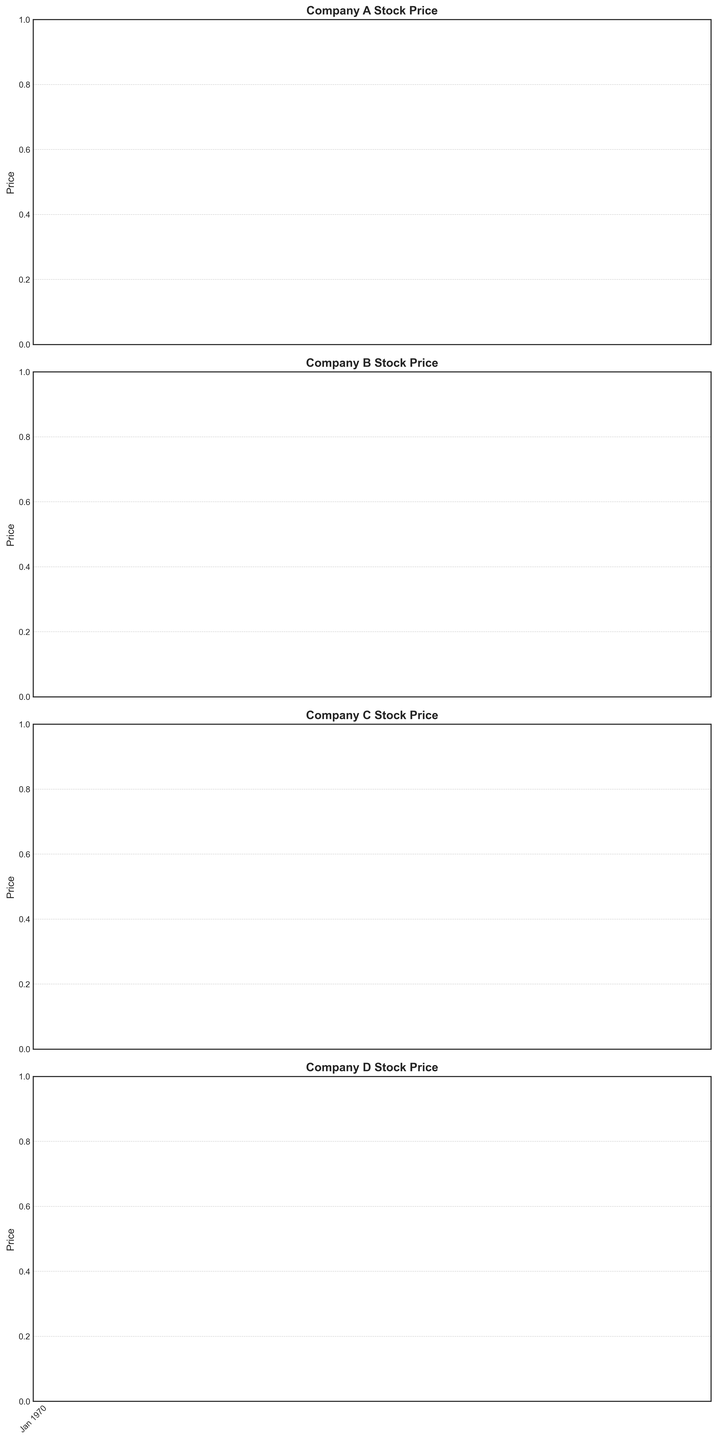What was the highest stock price for Company B in January 2023? Look at the candlestick chart for Company B in January 2023. The highest stock price for Company B in that month is marked visually at the peak of the candlestick.
Answer: 220 Compare the closing stock prices of Company A and Company C in June 2023. Which company had a higher closing price? Check the candlestick for Company A in June 2023 and note the closing price. Do the same for Company C. Compare the two values. Company A has a closing price of 130, and Company C has a closing price of 370.
Answer: Company C By how much did Company D's stock price increase from February 2023 to April 2023? Identify the closing prices for Company D in February 2023 and April 2023. Subtract the February closing price (420) from the April closing price (440).
Answer: 20 Calculate the average opening stock price for Company A from January 2023 to March 2023. Sum the opening prices of Company A for January (100), February (105), and March (110). Divide the total by the number of months. (100 + 105 + 110) / 3 = 105
Answer: 105 Which month did Company C experience the largest daily price range (difference between high and low prices)? For Company C, check the candlesticks for each month and calculate the difference between the highest and lowest prices. The month with the largest difference is the one with the largest range. In January 2023, the difference is 50 (330 - 280).
Answer: January 2023 For Company B, in which month was the stock's lowest price the highest? Review the candlestick chart for Company B and identify the month with the highest low price. August 2023 has the highest low price at 260.
Answer: August 2023 What color is most frequent for Company A’s candlesticks from January to June 2023? Observe all candlesticks for Company A from January to June 2023 and count the colors. Green indicates the stock closed higher than it opened; red indicates it closed lower. The candlestick colors are more frequently green in this period.
Answer: Green During which month did Company D experience the smallest difference between opening and closing prices? Examine each candlestick corresponding to Company D and calculate the difference between the opening and closing prices for each month. The smallest difference occurs in April 2023 with a difference of 10 (430 - 420).
Answer: April 2023 